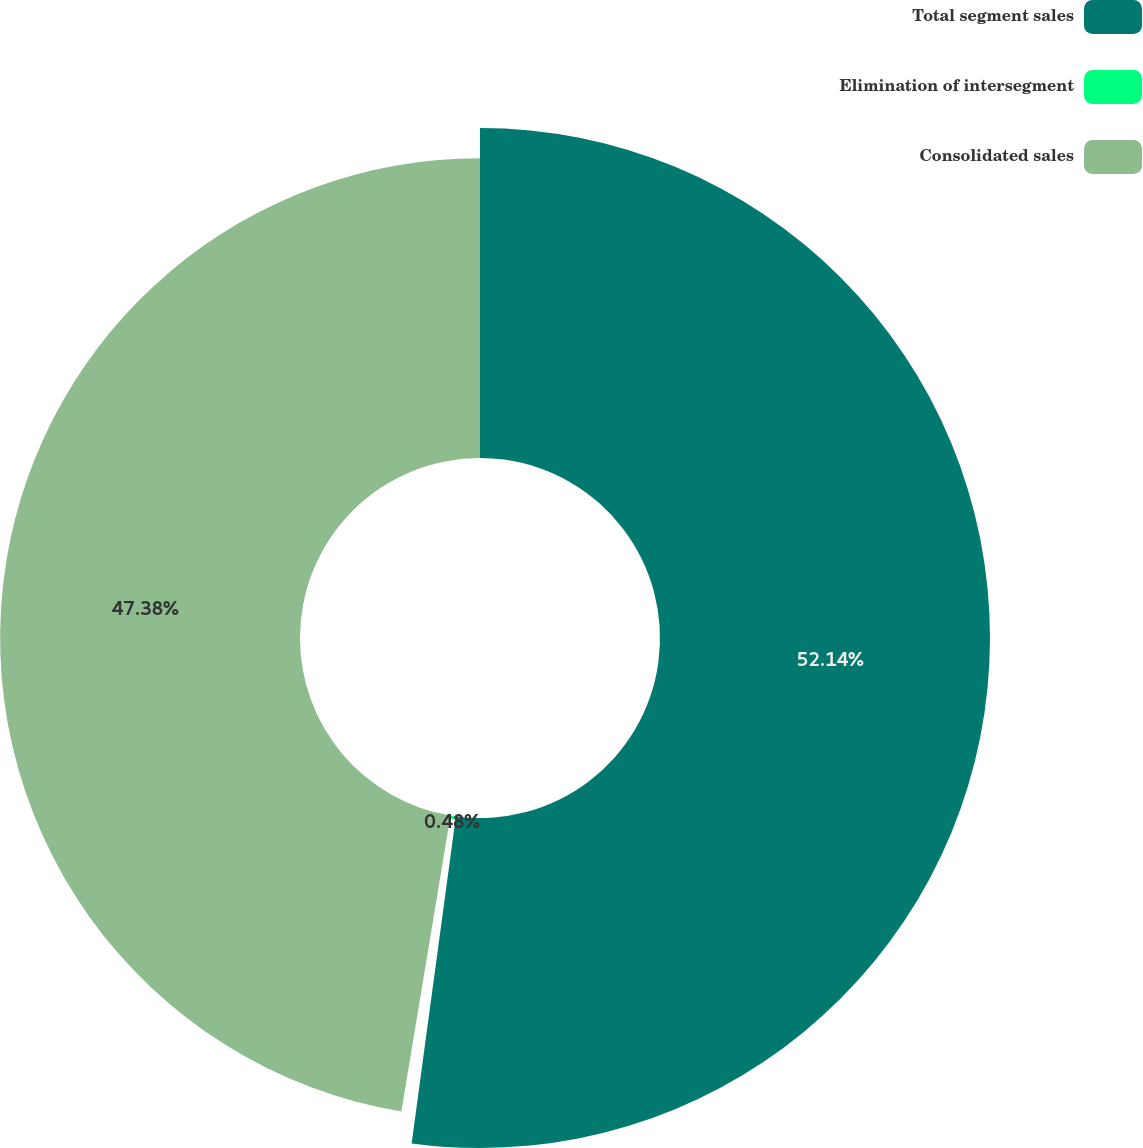<chart> <loc_0><loc_0><loc_500><loc_500><pie_chart><fcel>Total segment sales<fcel>Elimination of intersegment<fcel>Consolidated sales<nl><fcel>52.14%<fcel>0.48%<fcel>47.38%<nl></chart> 